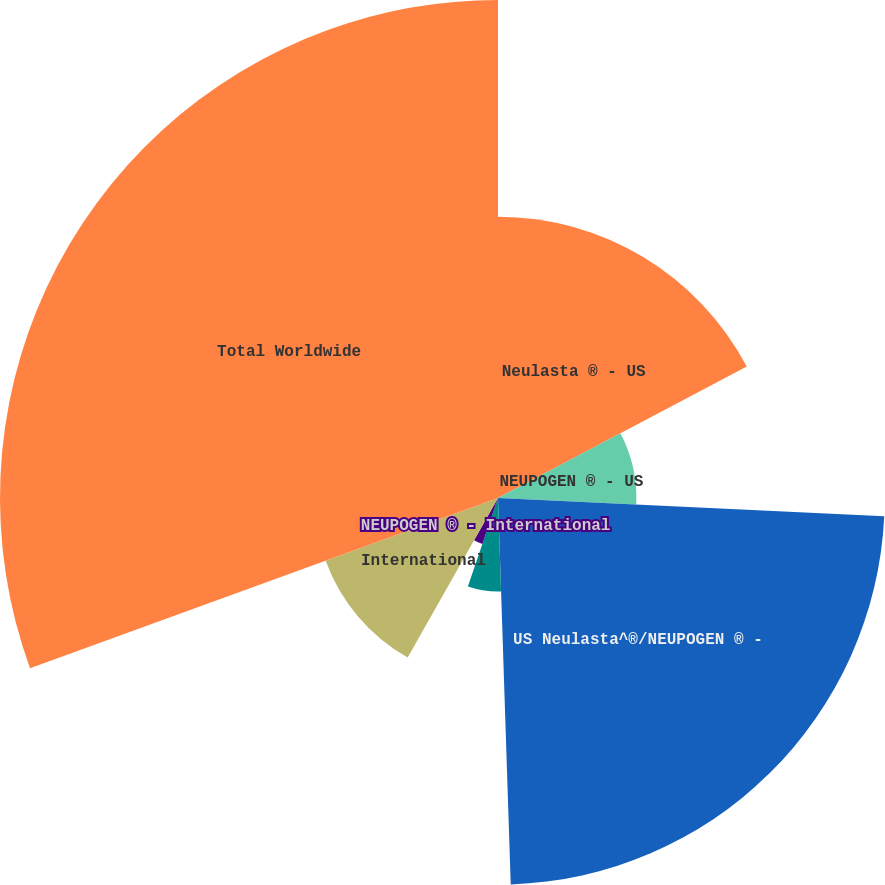<chart> <loc_0><loc_0><loc_500><loc_500><pie_chart><fcel>Neulasta ® - US<fcel>NEUPOGEN ® - US<fcel>US Neulasta^®/NEUPOGEN ® -<fcel>Neulasta ® - International<fcel>NEUPOGEN ® - International<fcel>International<fcel>Total Worldwide<nl><fcel>17.26%<fcel>8.49%<fcel>23.72%<fcel>5.74%<fcel>2.98%<fcel>11.25%<fcel>30.55%<nl></chart> 